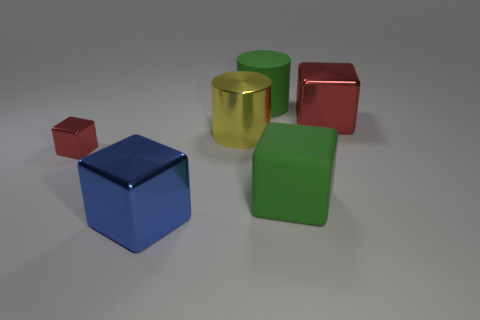Subtract all gray blocks. Subtract all purple cylinders. How many blocks are left? 4 Add 1 big metal blocks. How many objects exist? 7 Subtract all cylinders. How many objects are left? 4 Subtract all red blocks. Subtract all small metal cylinders. How many objects are left? 4 Add 4 red cubes. How many red cubes are left? 6 Add 1 large brown balls. How many large brown balls exist? 1 Subtract 0 gray blocks. How many objects are left? 6 